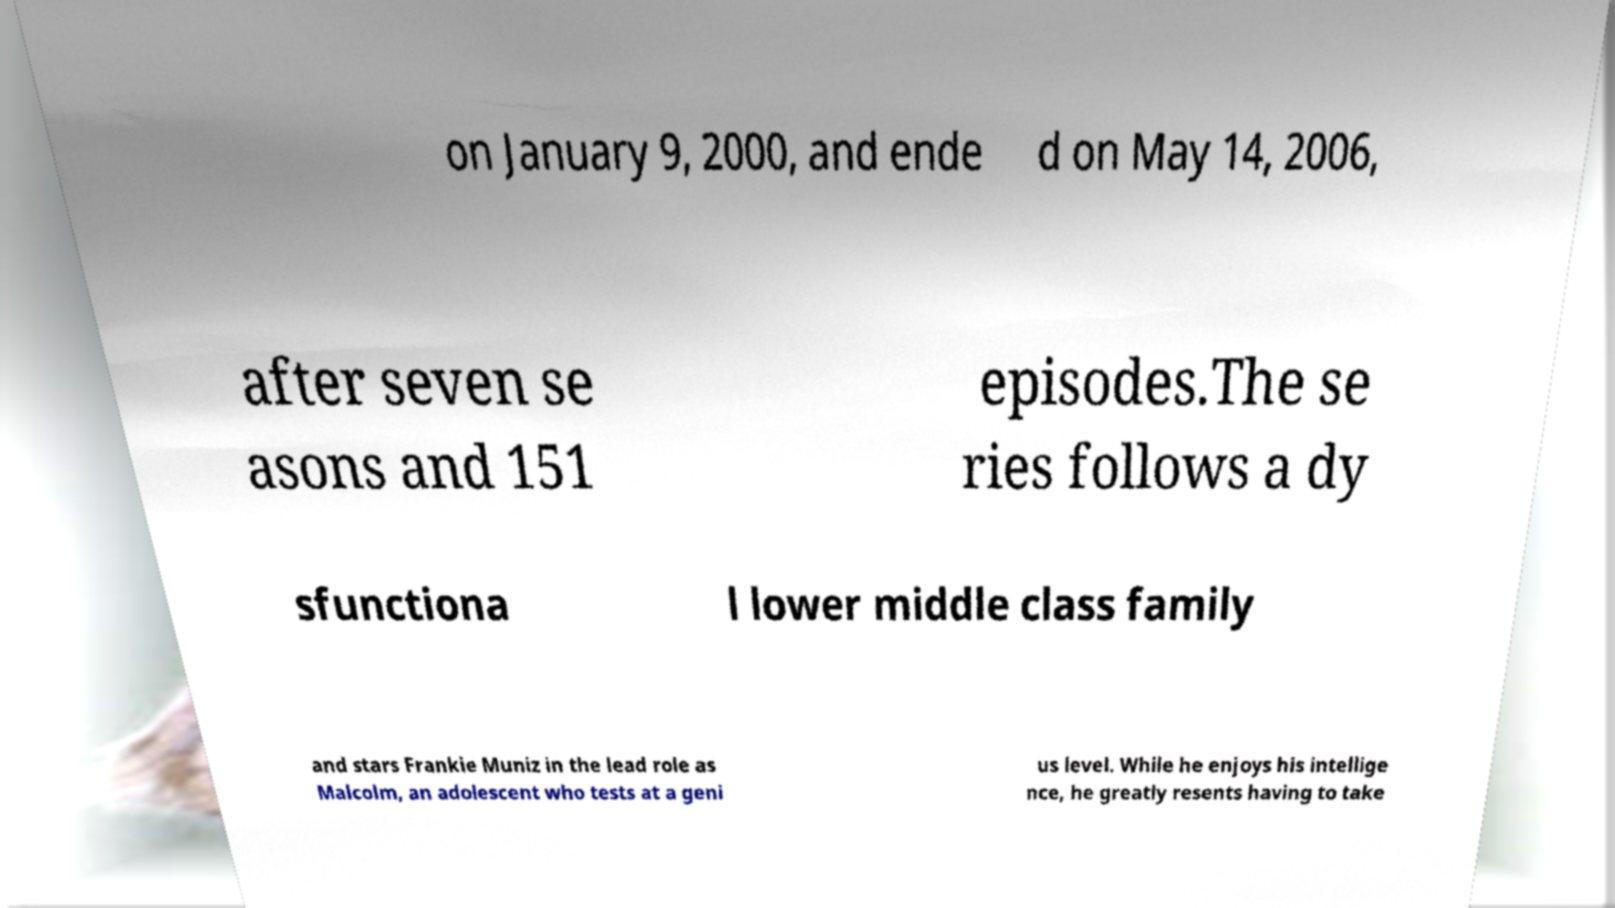Can you read and provide the text displayed in the image?This photo seems to have some interesting text. Can you extract and type it out for me? on January 9, 2000, and ende d on May 14, 2006, after seven se asons and 151 episodes.The se ries follows a dy sfunctiona l lower middle class family and stars Frankie Muniz in the lead role as Malcolm, an adolescent who tests at a geni us level. While he enjoys his intellige nce, he greatly resents having to take 